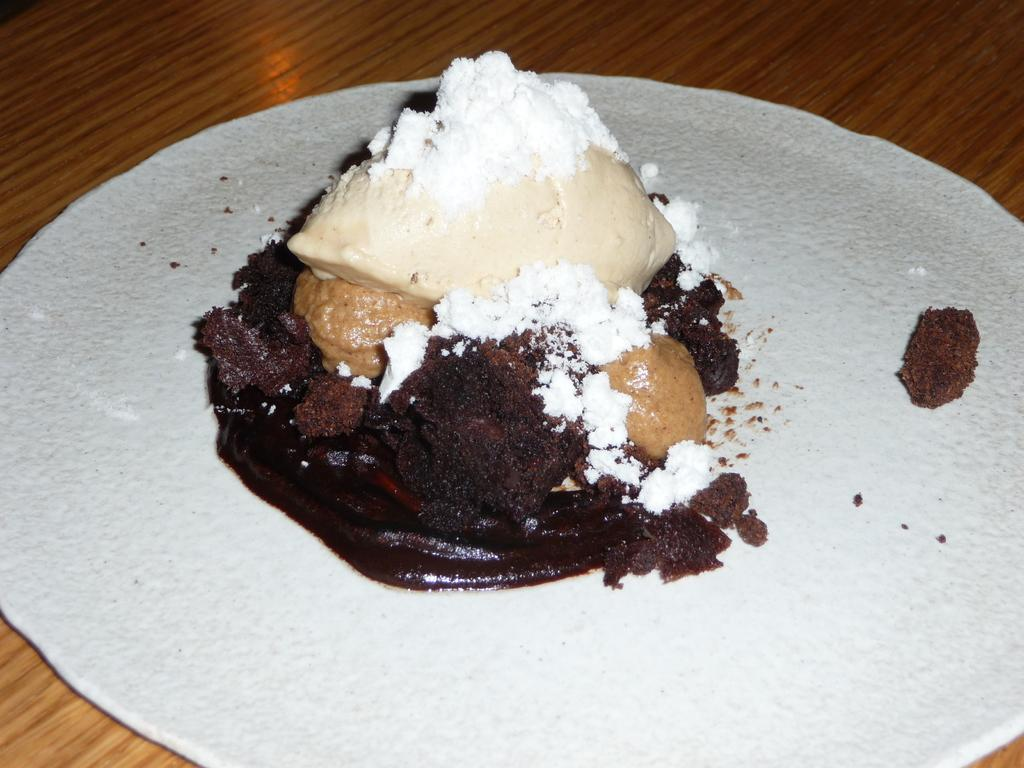What type of table is in the image? There is a wooden table in the image. What is on the table has a white surface? There is a white surface on the table. What is on the white surface? There is a food item with chocolate on the white surface. What else can be seen on the food item? There is white powder on the food item, along with other unspecified items. What is the opinion of the wax on the food item in the image? There is no wax present in the image, so it is not possible to determine its opinion. 